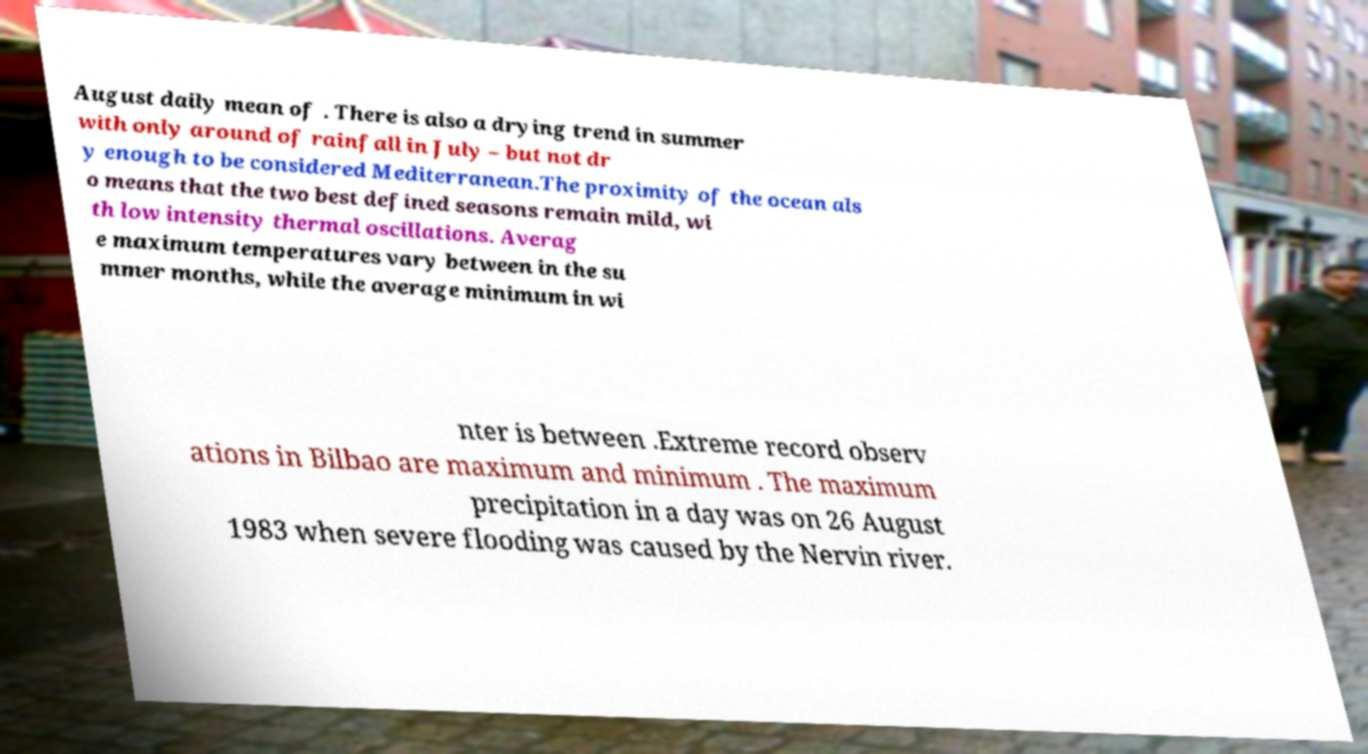Can you read and provide the text displayed in the image?This photo seems to have some interesting text. Can you extract and type it out for me? August daily mean of . There is also a drying trend in summer with only around of rainfall in July – but not dr y enough to be considered Mediterranean.The proximity of the ocean als o means that the two best defined seasons remain mild, wi th low intensity thermal oscillations. Averag e maximum temperatures vary between in the su mmer months, while the average minimum in wi nter is between .Extreme record observ ations in Bilbao are maximum and minimum . The maximum precipitation in a day was on 26 August 1983 when severe flooding was caused by the Nervin river. 